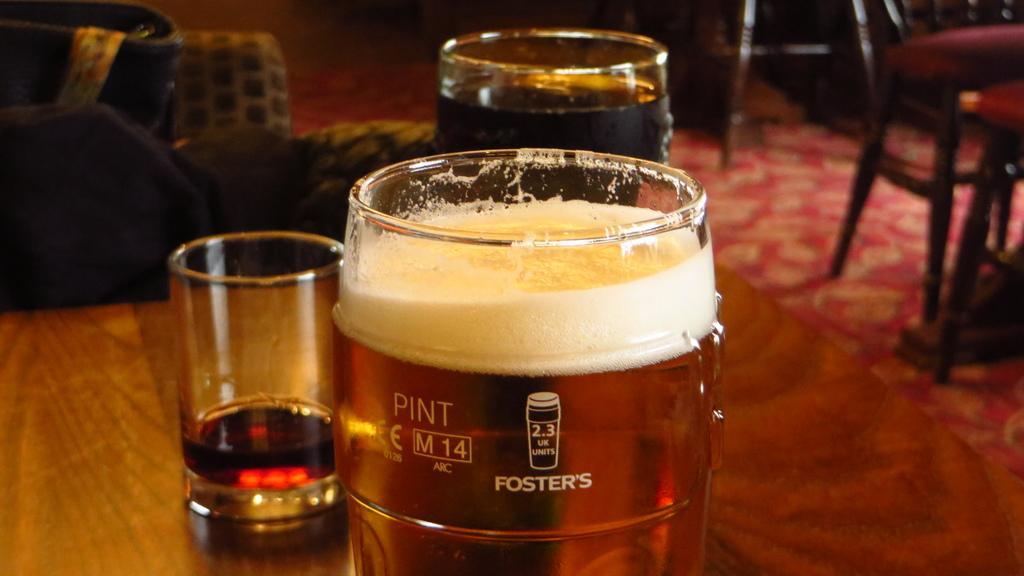Can you describe this image briefly? In this image I can see a glasses contain a drink and I can see a chairs on the right side. 